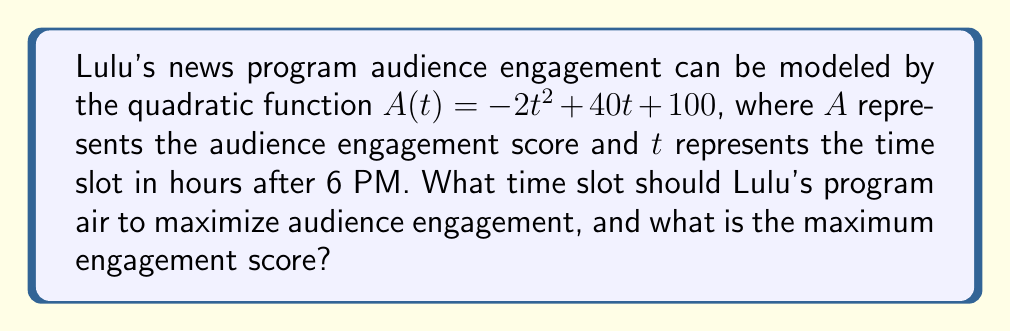Teach me how to tackle this problem. To solve this problem, we'll follow these steps:

1) The quadratic function is in the form $A(t) = -2t^2 + 40t + 100$, which is a parabola that opens downward due to the negative coefficient of $t^2$.

2) To find the maximum point of a parabola, we need to find the vertex. For a quadratic function in the form $f(x) = ax^2 + bx + c$, the x-coordinate of the vertex is given by $x = -\frac{b}{2a}$.

3) In our case, $a = -2$ and $b = 40$. Let's calculate the t-coordinate of the vertex:

   $t = -\frac{40}{2(-2)} = -\frac{40}{-4} = 10$

4) This means the optimal time slot is 10 hours after 6 PM, which is 4 AM the next day.

5) To find the maximum engagement score, we substitute $t = 10$ into the original function:

   $A(10) = -2(10)^2 + 40(10) + 100$
   $= -2(100) + 400 + 100$
   $= -200 + 400 + 100$
   $= 300$

Therefore, the maximum engagement score is 300.
Answer: The optimal time slot is 10 hours after 6 PM (4 AM the next day), and the maximum engagement score is 300. 